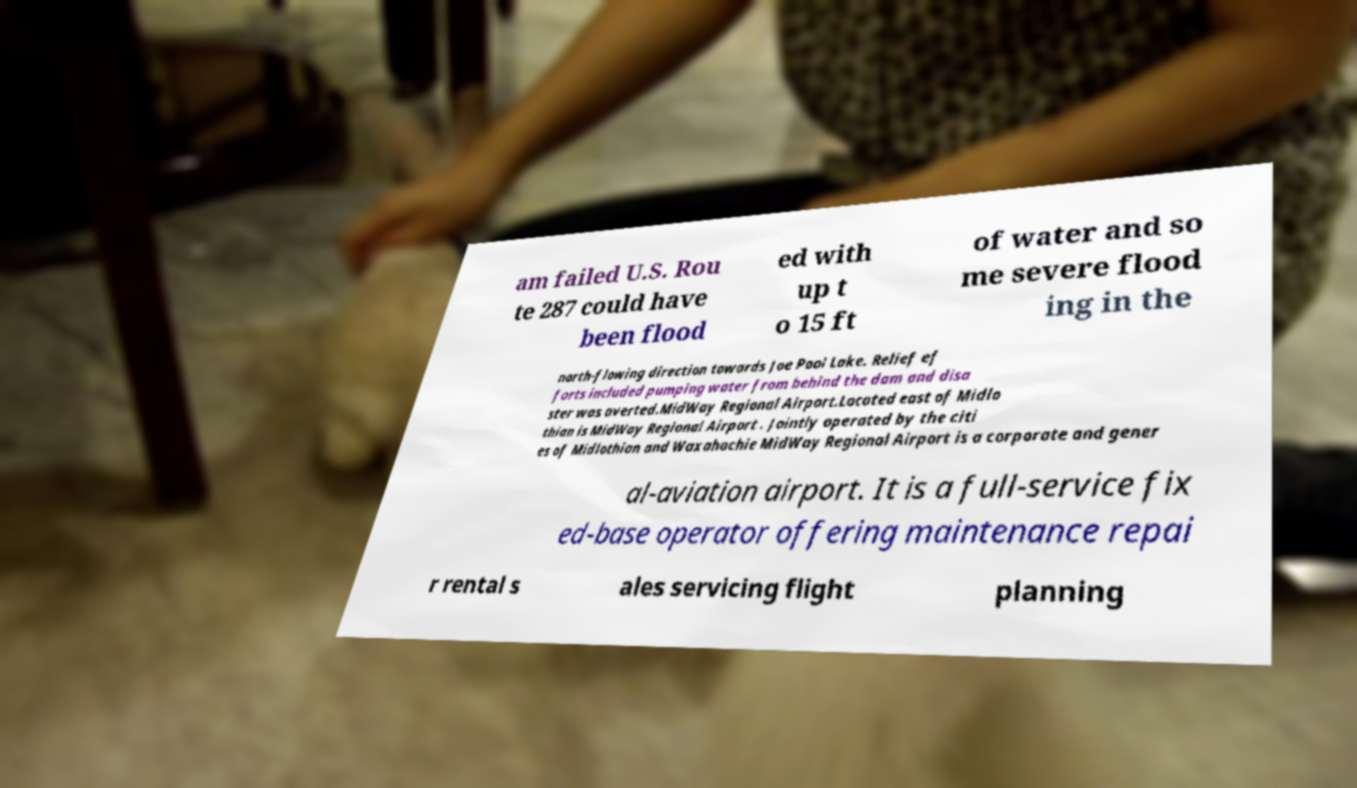There's text embedded in this image that I need extracted. Can you transcribe it verbatim? am failed U.S. Rou te 287 could have been flood ed with up t o 15 ft of water and so me severe flood ing in the north-flowing direction towards Joe Pool Lake. Relief ef forts included pumping water from behind the dam and disa ster was averted.MidWay Regional Airport.Located east of Midlo thian is MidWay Regional Airport . Jointly operated by the citi es of Midlothian and Waxahachie MidWay Regional Airport is a corporate and gener al-aviation airport. It is a full-service fix ed-base operator offering maintenance repai r rental s ales servicing flight planning 